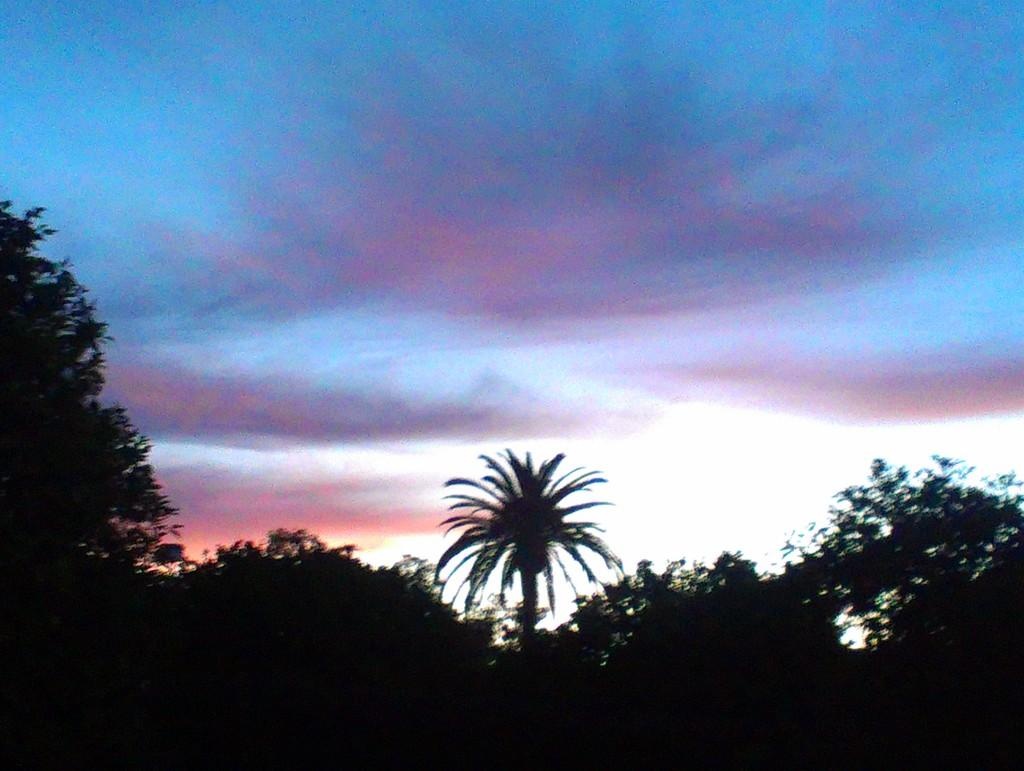What type of vegetation can be seen in the image? There are many trees in the image. What can be seen in the sky in the image? There are clouds visible in the sky in the image. What is the chance of winning the lottery in the image? There is no information about the lottery or winning chances in the image. Is there any debt mentioned or depicted in the image? There is no mention or depiction of debt in the image. 